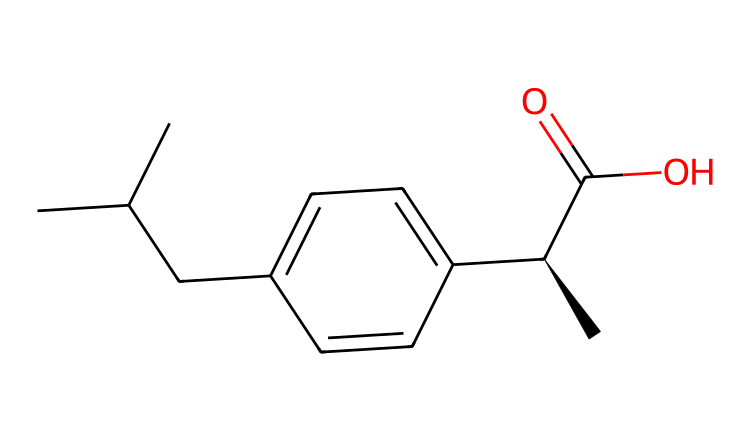What is the name of this chemical? The SMILES representation indicates the specific arrangement of atoms. The structure corresponds to ibuprofen, which is a well-known nonsteroidal anti-inflammatory drug (NSAID).
Answer: ibuprofen How many carbon atoms are in the structure? In the SMILES string, each 'C' denotes a carbon atom, and upon counting them, there are 13 carbon atoms in the structure of ibuprofen.
Answer: 13 What functional group is present in this molecule? The presence of 'C(=O)O' in the SMILES indicates the presence of a carboxylic acid functional group, which is characteristic of ibuprofen.
Answer: carboxylic acid What is the stereocenter in this chemical? The chiral center is indicated by '[C@H]', which signifies that this carbon atom has four different substituents, making the molecule chiral. This is a stereocenter in ibuprofen's structure.
Answer: [C@H] How many double bonds are present in the structure? In the SMILES, there is one double bond represented by 'C(=O)' and no other parts indicate any additional double bonds. Therefore, there is just one double bond in ibuprofen.
Answer: 1 What type of isomerism does ibuprofen display? Ibuprofen can exhibit stereoisomerism due to the presence of a chiral center. Therefore, it can exist as two enantiomers.
Answer: stereoisomerism Is this molecule polar or nonpolar? The presence of the polar -COOH group suggests that ibuprofen is polar due to the ability of this group to engage in hydrogen bonding, contrasting with the nonpolar hydrocarbon part of the molecule.
Answer: polar 